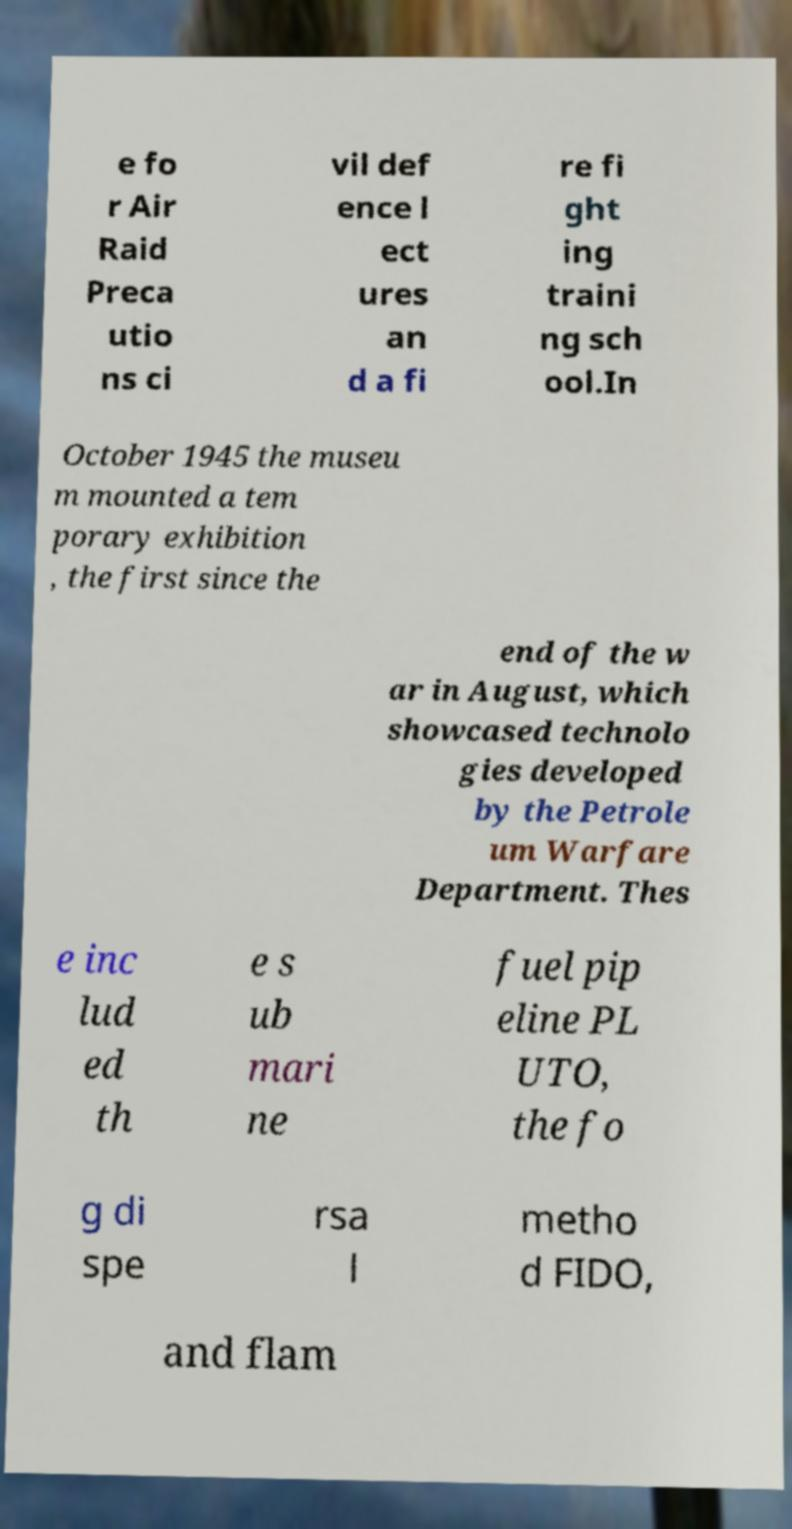Could you assist in decoding the text presented in this image and type it out clearly? e fo r Air Raid Preca utio ns ci vil def ence l ect ures an d a fi re fi ght ing traini ng sch ool.In October 1945 the museu m mounted a tem porary exhibition , the first since the end of the w ar in August, which showcased technolo gies developed by the Petrole um Warfare Department. Thes e inc lud ed th e s ub mari ne fuel pip eline PL UTO, the fo g di spe rsa l metho d FIDO, and flam 